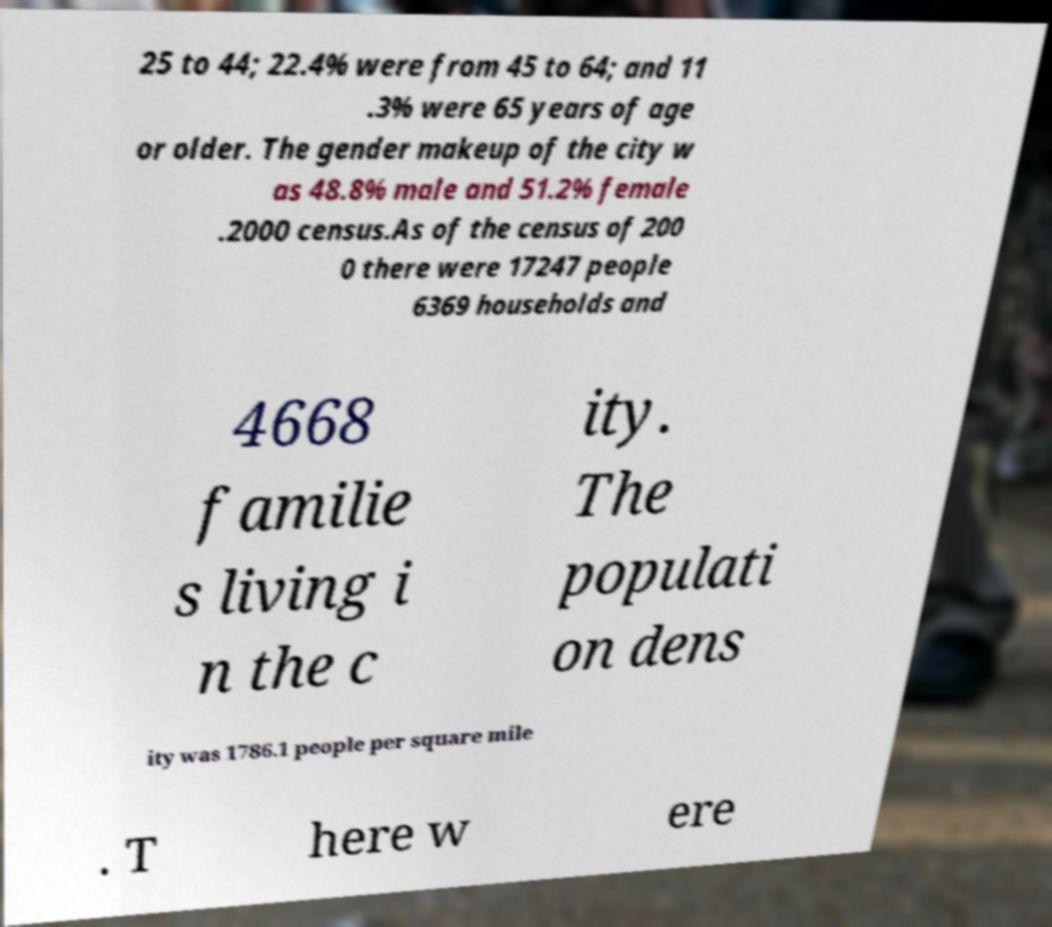Please read and relay the text visible in this image. What does it say? 25 to 44; 22.4% were from 45 to 64; and 11 .3% were 65 years of age or older. The gender makeup of the city w as 48.8% male and 51.2% female .2000 census.As of the census of 200 0 there were 17247 people 6369 households and 4668 familie s living i n the c ity. The populati on dens ity was 1786.1 people per square mile . T here w ere 